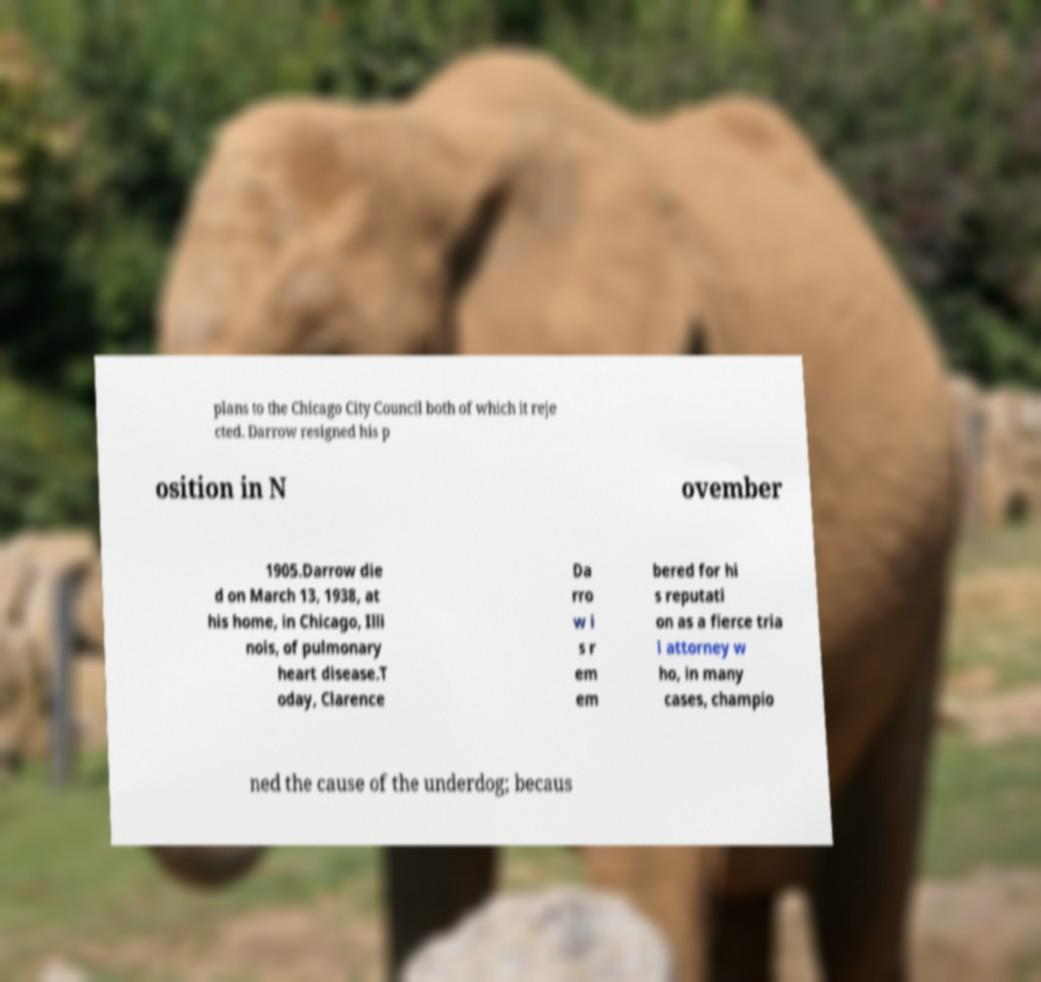What messages or text are displayed in this image? I need them in a readable, typed format. plans to the Chicago City Council both of which it reje cted. Darrow resigned his p osition in N ovember 1905.Darrow die d on March 13, 1938, at his home, in Chicago, Illi nois, of pulmonary heart disease.T oday, Clarence Da rro w i s r em em bered for hi s reputati on as a fierce tria l attorney w ho, in many cases, champio ned the cause of the underdog; becaus 